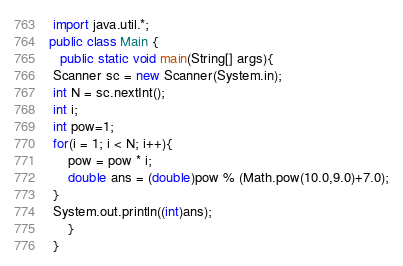Convert code to text. <code><loc_0><loc_0><loc_500><loc_500><_Java_> import java.util.*;  
public class Main {
   public static void main(String[] args){
 Scanner sc = new Scanner(System.in);
 int N = sc.nextInt();
 int i;
 int pow=1;
 for(i = 1; i < N; i++){
     pow = pow * i;
     double ans = (double)pow % (Math.pow(10.0,9.0)+7.0);
 }
 System.out.println((int)ans);
     }
 }
</code> 